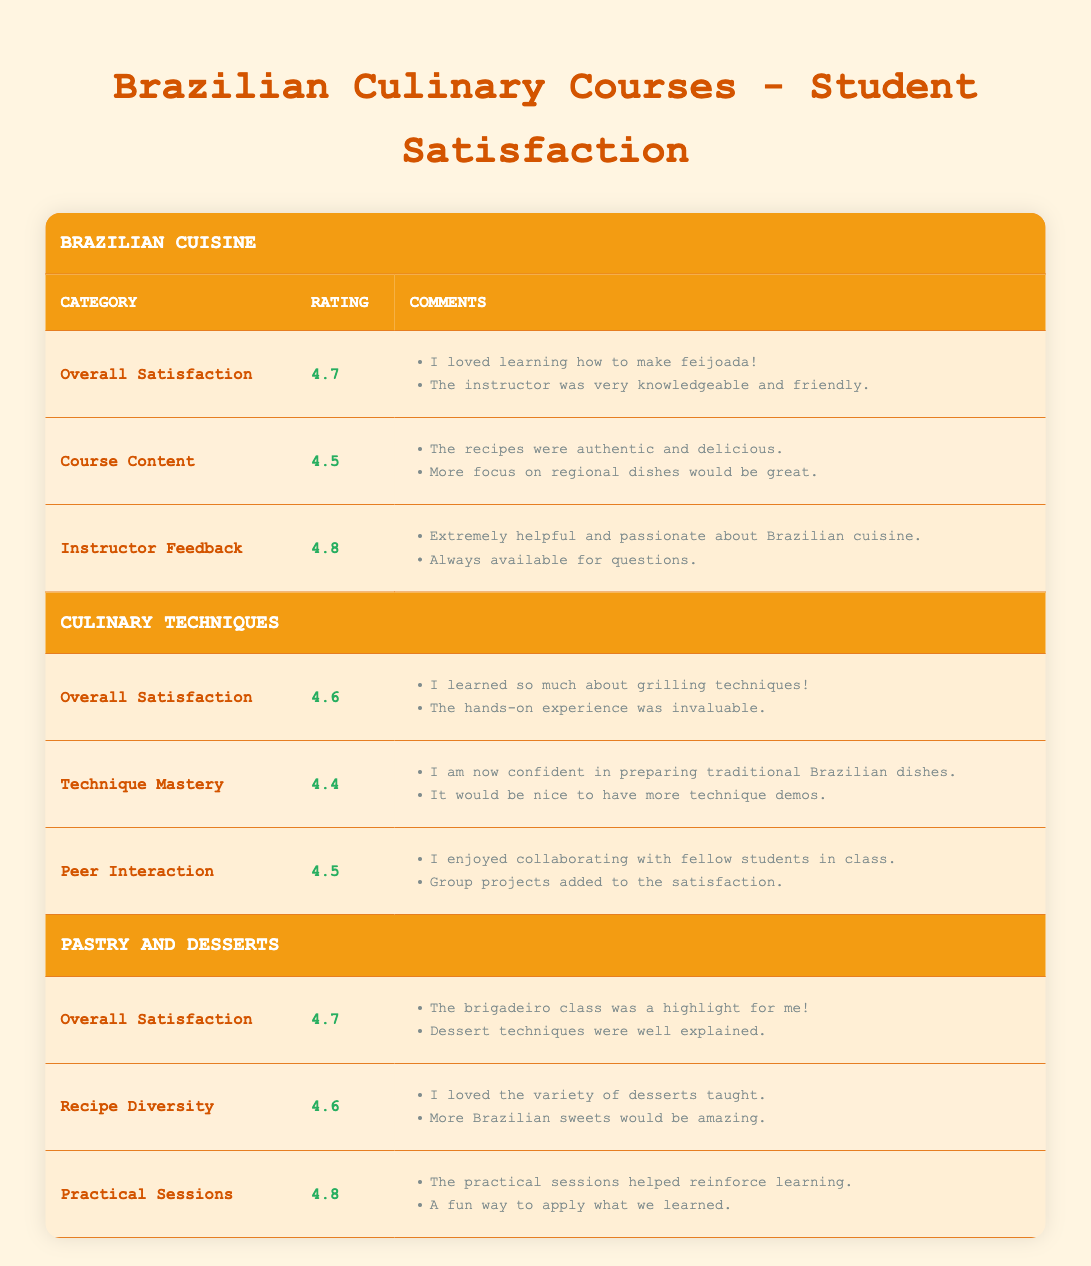What is the overall satisfaction rating for the Brazilian Cuisine course? The Brazilian Cuisine course has an overall satisfaction rating listed in the table, which is 4.7.
Answer: 4.7 What were the comments regarding instructor feedback in the Culinary Techniques section? The comments under instructor feedback in the Culinary Techniques section include: "Extremely helpful and passionate about Brazilian cuisine." and "Always available for questions."
Answer: "Extremely helpful and passionate about Brazilian cuisine." and "Always available for questions." What is the difference between the overall satisfaction ratings of Brazilian Cuisine and Pastry and Desserts courses? The overall satisfaction rating for Brazilian Cuisine is 4.7 and for Pastry and Desserts, it is also 4.7. Therefore, the difference is 4.7 - 4.7 = 0.
Answer: 0 Is the rating for Practical Sessions higher than that for Course Content in the Brazilian Cuisine section? The rating for Practical Sessions in Pastry and Desserts is 4.8, while Course Content in Brazilian Cuisine is rated 4.5. Since 4.8 is greater than 4.5, the answer is yes.
Answer: Yes What is the average rating of Overall Satisfaction between both culinary courses? The Overall Satisfaction rating for Brazilian Cuisine is 4.7 and for Pastry and Desserts, it is also 4.7. To find the average, we add these ratings: (4.7 + 4.7) / 2 = 4.7.
Answer: 4.7 How many comments were made regarding the technique mastery in Culinary Techniques? In the Technique Mastery section, there are two comments: "I am now confident in preparing traditional Brazilian dishes." and "It would be nice to have more technique demos." thus the count is two.
Answer: 2 What is the highest rated feedback among all categories in the table? The highest rating in the table is 4.8 under the Practical Sessions in the Pastry and Desserts section, and associated comments reinforce the positivity of this feedback.
Answer: 4.8 Would students want more Brazilian sweets in the Pastry and Desserts course according to their comments? Yes, one of the comments under Recipe Diversity states, "More Brazilian sweets would be amazing," indicating a desire for more Brazilian sweets.
Answer: Yes What is the total number of comments provided in the Overall Satisfaction categories of both courses? Brazilian Cuisine has two comments and Pastry and Desserts have two comments under Overall Satisfaction. Therefore, the total number of comments is 2 + 2 = 4.
Answer: 4 